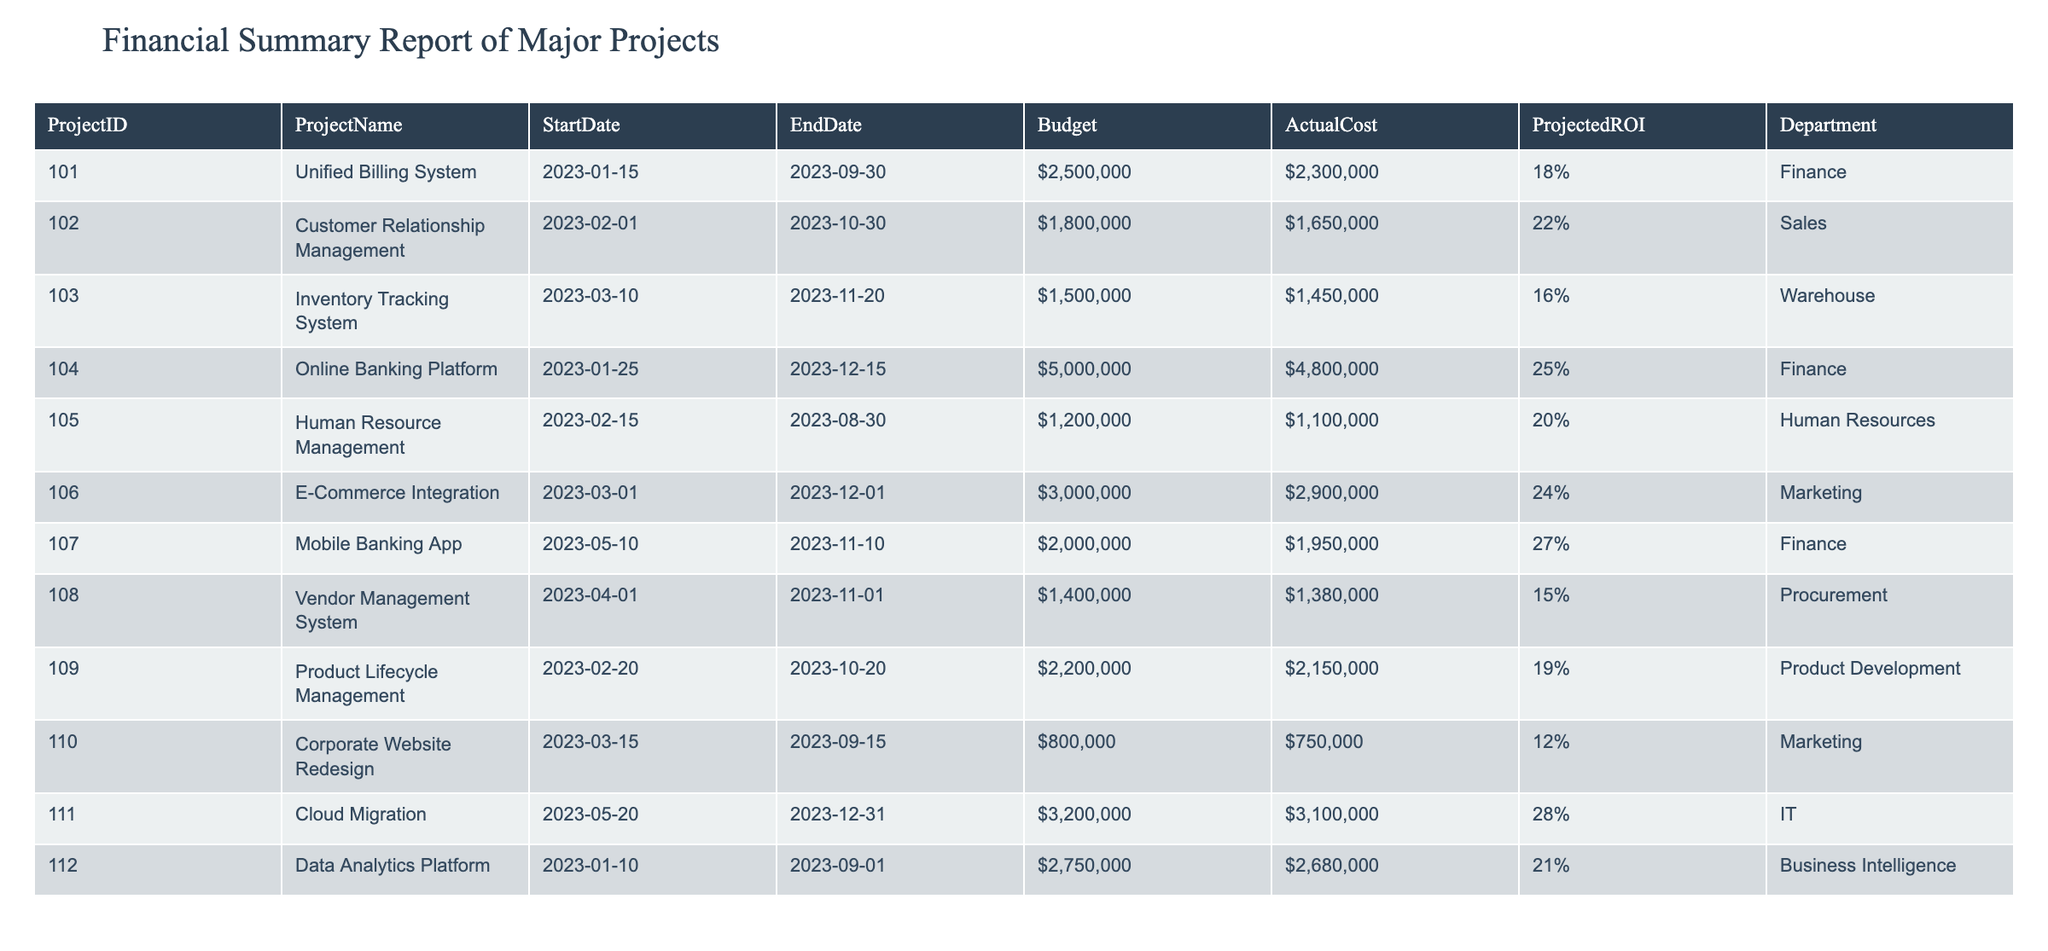What is the total budget allocated for all projects? To find the total budget, sum all the individual budgets listed in the table: 2500000 + 1800000 + 1500000 + 5000000 + 1200000 + 3000000 + 2000000 + 1400000 + 2200000 + 800000 + 3200000 + 2750000 = 22700000
Answer: 22700000 Which project has the highest projected ROI? The table indicates the projected ROIs for each project. Comparing these values, "Mobile Banking App" has the highest projected ROI of 27%.
Answer: Mobile Banking App Is the actual cost of the "E-Commerce Integration" project less than its budget? The budget for "E-Commerce Integration" is 3000000 and its actual cost is 2900000. Since 2900000 is less than 3000000, the statement is true.
Answer: Yes What is the difference between the total budget and the total actual cost of all projects? First, calculate the total actual cost, which is 2300000 + 1650000 + 1450000 + 4800000 + 1100000 + 2900000 + 1950000 + 1380000 + 2150000 + 750000 + 3100000 + 2680000 = 20550000. Then, find the difference: 22700000 - 20550000 = 2150000.
Answer: 2150000 Are there any projects from the Finance department with an actual cost greater than the budget? The finance projects include "Unified Billing System", "Online Banking Platform", and "Mobile Banking App". Checking their actual costs against their budgets: 2300000 <= 2500000, 4800000 <= 5000000, and 1950000 <= 2000000. All actual costs are less than their respective budgets, so the answer is false.
Answer: No What is the average projected ROI of projects in the Human Resources and Marketing departments? Projects in Human Resources and Marketing are "Human Resource Management" with a ROI of 20% and "E-Commerce Integration" with a ROI of 24%, respectively. The average is calculated by (20% + 24%) / 2 = 22%.
Answer: 22% Which project ended first, and what is its end date? Review the end dates to find the earliest one. "Unified Billing System" ends on 2023-09-30, which is earlier than the others.
Answer: 2023-09-30 How many projects have an actual cost less than 2 million? Looking at the actual costs, the projects with costs less than 2 million are "Customer Relationship Management", "Inventory Tracking System", "Human Resource Management", "Corporate Website Redesign", and "Vendor Management System". There are 5 such projects.
Answer: 5 What is the projected ROI of the project with the shortest duration? The project with the shortest duration is "Corporate Website Redesign" (2023-03-15 to 2023-09-15), which lasts 6 months. Its projected ROI is 12%.
Answer: 12% 